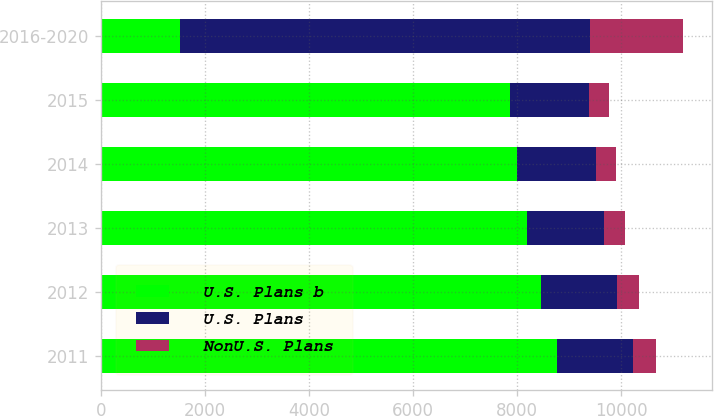<chart> <loc_0><loc_0><loc_500><loc_500><stacked_bar_chart><ecel><fcel>2011<fcel>2012<fcel>2013<fcel>2014<fcel>2015<fcel>2016-2020<nl><fcel>U.S. Plans b<fcel>8765<fcel>8463<fcel>8186<fcel>7999<fcel>7855<fcel>1513<nl><fcel>U.S. Plans<fcel>1460<fcel>1461<fcel>1480<fcel>1513<fcel>1534<fcel>7889<nl><fcel>NonU.S. Plans<fcel>451<fcel>427<fcel>407<fcel>391<fcel>379<fcel>1796<nl></chart> 